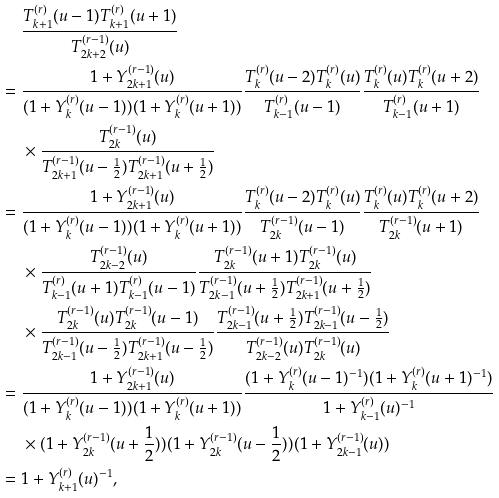Convert formula to latex. <formula><loc_0><loc_0><loc_500><loc_500>& \quad \ \frac { T _ { k + 1 } ^ { ( r ) } ( u - 1 ) T _ { k + 1 } ^ { ( r ) } ( u + 1 ) } { T _ { 2 k + 2 } ^ { ( r - 1 ) } ( u ) } \\ & = \frac { 1 + Y _ { 2 k + 1 } ^ { ( r - 1 ) } ( u ) } { ( 1 + Y _ { k } ^ { ( r ) } ( u - 1 ) ) ( 1 + Y _ { k } ^ { ( r ) } ( u + 1 ) ) } \frac { T _ { k } ^ { ( r ) } ( u - 2 ) T _ { k } ^ { ( r ) } ( u ) } { T _ { k - 1 } ^ { ( r ) } ( u - 1 ) } \frac { T _ { k } ^ { ( r ) } ( u ) T _ { k } ^ { ( r ) } ( u + 2 ) } { T _ { k - 1 } ^ { ( r ) } ( u + 1 ) } \\ & \quad \ \times \frac { T _ { 2 k } ^ { ( r - 1 ) } ( u ) } { T _ { 2 k + 1 } ^ { ( r - 1 ) } ( u - \frac { 1 } { 2 } ) T _ { 2 k + 1 } ^ { ( r - 1 ) } ( u + \frac { 1 } { 2 } ) } \\ & = \frac { 1 + Y _ { 2 k + 1 } ^ { ( r - 1 ) } ( u ) } { ( 1 + Y _ { k } ^ { ( r ) } ( u - 1 ) ) ( 1 + Y _ { k } ^ { ( r ) } ( u + 1 ) ) } \frac { T _ { k } ^ { ( r ) } ( u - 2 ) T _ { k } ^ { ( r ) } ( u ) } { T _ { 2 k } ^ { ( r - 1 ) } ( u - 1 ) } \frac { T _ { k } ^ { ( r ) } ( u ) T _ { k } ^ { ( r ) } ( u + 2 ) } { T _ { 2 k } ^ { ( r - 1 ) } ( u + 1 ) } \ \\ & \quad \ \times \frac { T _ { 2 k - 2 } ^ { ( r - 1 ) } ( u ) } { T _ { k - 1 } ^ { ( r ) } ( u + 1 ) T _ { k - 1 } ^ { ( r ) } ( u - 1 ) } \frac { T _ { 2 k } ^ { ( r - 1 ) } ( u + 1 ) T _ { 2 k } ^ { ( r - 1 ) } ( u ) } { T _ { 2 k - 1 } ^ { ( r - 1 ) } ( u + \frac { 1 } { 2 } ) T _ { 2 k + 1 } ^ { ( r - 1 ) } ( u + \frac { 1 } { 2 } ) } \\ & \quad \ \times \frac { T _ { 2 k } ^ { ( r - 1 ) } ( u ) T _ { 2 k } ^ { ( r - 1 ) } ( u - 1 ) } { T _ { 2 k - 1 } ^ { ( r - 1 ) } ( u - \frac { 1 } { 2 } ) T _ { 2 k + 1 } ^ { ( r - 1 ) } ( u - \frac { 1 } { 2 } ) } \frac { T _ { 2 k - 1 } ^ { ( r - 1 ) } ( u + \frac { 1 } { 2 } ) T _ { 2 k - 1 } ^ { ( r - 1 ) } ( u - \frac { 1 } { 2 } ) } { T _ { 2 k - 2 } ^ { ( r - 1 ) } ( u ) T _ { 2 k } ^ { ( r - 1 ) } ( u ) } \\ & = \frac { 1 + Y _ { 2 k + 1 } ^ { ( r - 1 ) } ( u ) } { ( 1 + Y _ { k } ^ { ( r ) } ( u - 1 ) ) ( 1 + Y _ { k } ^ { ( r ) } ( u + 1 ) ) } \frac { ( 1 + Y _ { k } ^ { ( r ) } ( u - 1 ) ^ { - 1 } ) ( 1 + Y _ { k } ^ { ( r ) } ( u + 1 ) ^ { - 1 } ) } { 1 + Y _ { k - 1 } ^ { ( r ) } ( u ) ^ { - 1 } } \\ & \quad \ \times ( 1 + Y _ { 2 k } ^ { ( r - 1 ) } ( u + \frac { 1 } { 2 } ) ) ( 1 + Y _ { 2 k } ^ { ( r - 1 ) } ( u - \frac { 1 } { 2 } ) ) ( 1 + Y _ { 2 k - 1 } ^ { ( r - 1 ) } ( u ) ) \\ & = 1 + Y _ { k + 1 } ^ { ( r ) } ( u ) ^ { - 1 } ,</formula> 